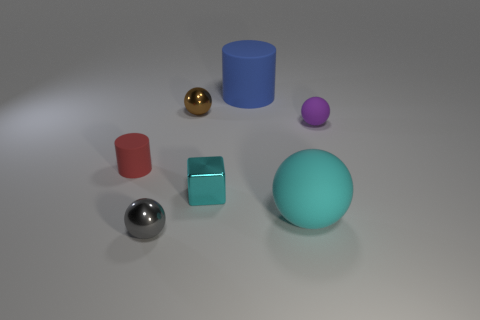Are there any purple things of the same size as the gray metal thing?
Your response must be concise. Yes. What color is the other matte thing that is the same shape as the cyan rubber thing?
Make the answer very short. Purple. There is a metal sphere behind the large cyan matte sphere; does it have the same size as the matte cylinder to the right of the gray shiny sphere?
Give a very brief answer. No. Are there any tiny gray metal objects that have the same shape as the purple thing?
Keep it short and to the point. Yes. Are there an equal number of big blue matte things in front of the brown ball and large yellow shiny objects?
Offer a very short reply. Yes. Do the blue object and the metal thing that is in front of the tiny metallic block have the same size?
Your answer should be compact. No. What number of other brown objects are made of the same material as the brown thing?
Provide a short and direct response. 0. Do the blue rubber cylinder and the cyan rubber object have the same size?
Ensure brevity in your answer.  Yes. Are there any other things that are the same color as the cube?
Your response must be concise. Yes. The tiny metallic object that is both in front of the tiny brown metal thing and behind the gray metal ball has what shape?
Your answer should be very brief. Cube. 